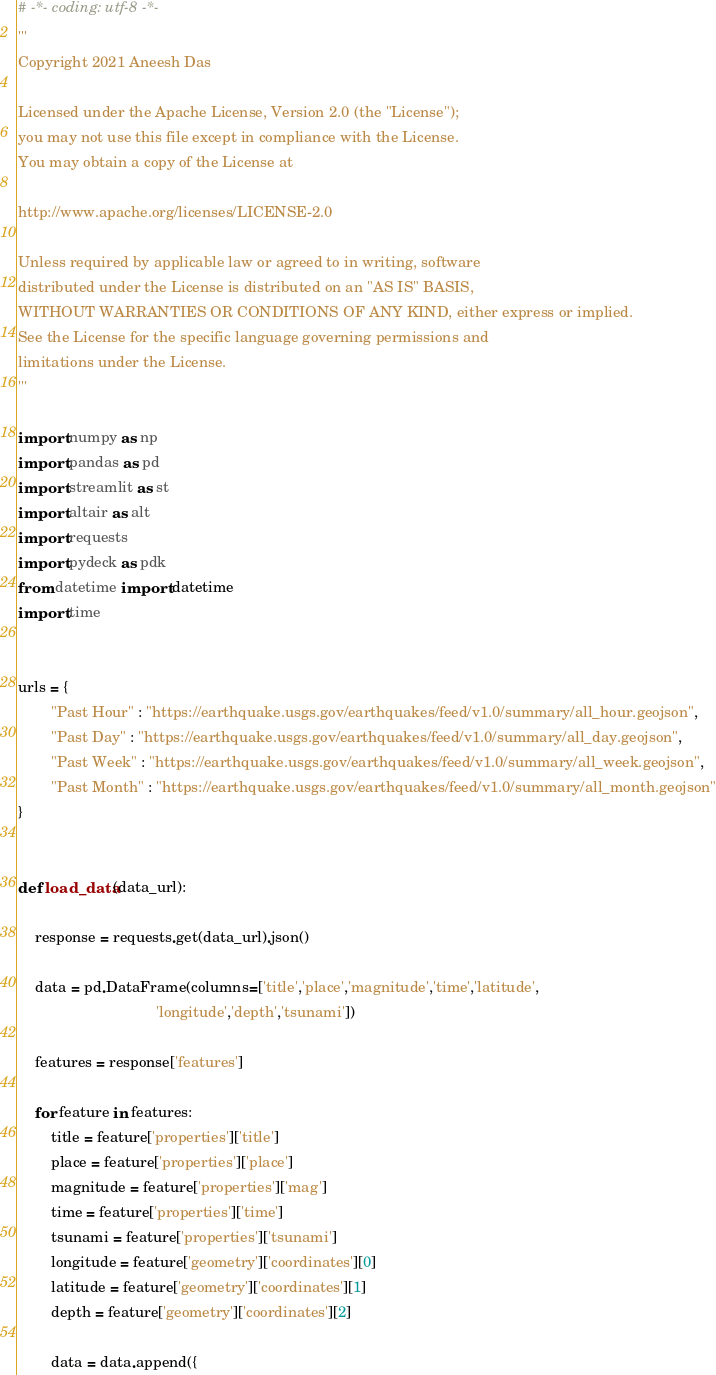<code> <loc_0><loc_0><loc_500><loc_500><_Python_># -*- coding: utf-8 -*-
'''
Copyright 2021 Aneesh Das

Licensed under the Apache License, Version 2.0 (the "License");
you may not use this file except in compliance with the License.
You may obtain a copy of the License at

http://www.apache.org/licenses/LICENSE-2.0

Unless required by applicable law or agreed to in writing, software
distributed under the License is distributed on an "AS IS" BASIS,
WITHOUT WARRANTIES OR CONDITIONS OF ANY KIND, either express or implied.
See the License for the specific language governing permissions and
limitations under the License.
'''

import numpy as np
import pandas as pd
import streamlit as st
import altair as alt
import requests
import pydeck as pdk
from datetime import datetime
import time


urls = { 
        "Past Hour" : "https://earthquake.usgs.gov/earthquakes/feed/v1.0/summary/all_hour.geojson",
        "Past Day" : "https://earthquake.usgs.gov/earthquakes/feed/v1.0/summary/all_day.geojson",
        "Past Week" : "https://earthquake.usgs.gov/earthquakes/feed/v1.0/summary/all_week.geojson",
        "Past Month" : "https://earthquake.usgs.gov/earthquakes/feed/v1.0/summary/all_month.geojson"
}


def load_data(data_url):
    
    response = requests.get(data_url).json()
    
    data = pd.DataFrame(columns=['title','place','magnitude','time','latitude',
                                 'longitude','depth','tsunami'])
    
    features = response['features']
    
    for feature in features:
        title = feature['properties']['title']
        place = feature['properties']['place']
        magnitude = feature['properties']['mag']
        time = feature['properties']['time']
        tsunami = feature['properties']['tsunami']
        longitude = feature['geometry']['coordinates'][0]
        latitude = feature['geometry']['coordinates'][1]
        depth = feature['geometry']['coordinates'][2]
        
        data = data.append({</code> 